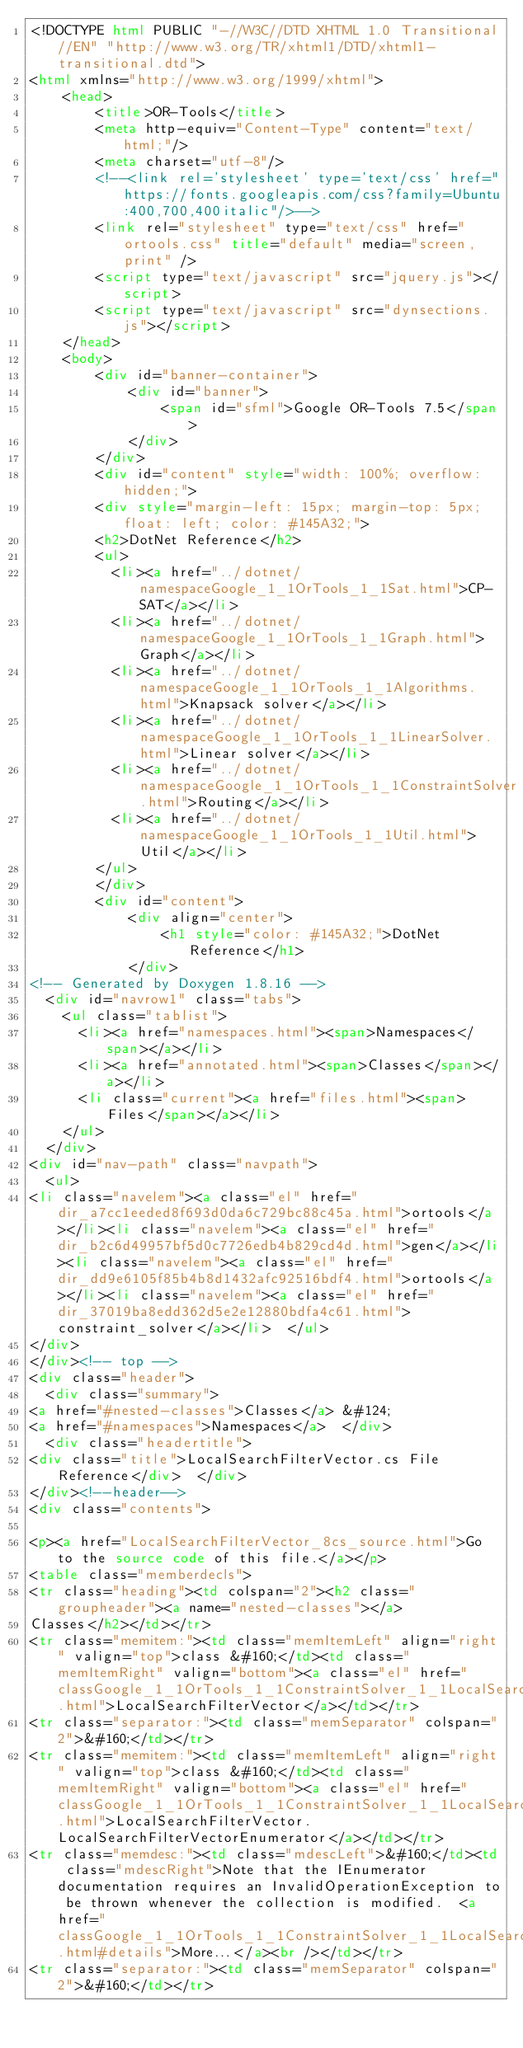Convert code to text. <code><loc_0><loc_0><loc_500><loc_500><_HTML_><!DOCTYPE html PUBLIC "-//W3C//DTD XHTML 1.0 Transitional//EN" "http://www.w3.org/TR/xhtml1/DTD/xhtml1-transitional.dtd">
<html xmlns="http://www.w3.org/1999/xhtml">
    <head>
        <title>OR-Tools</title>
        <meta http-equiv="Content-Type" content="text/html;"/>
        <meta charset="utf-8"/>
        <!--<link rel='stylesheet' type='text/css' href="https://fonts.googleapis.com/css?family=Ubuntu:400,700,400italic"/>-->
        <link rel="stylesheet" type="text/css" href="ortools.css" title="default" media="screen,print" />
        <script type="text/javascript" src="jquery.js"></script>
        <script type="text/javascript" src="dynsections.js"></script>
    </head>
    <body>
        <div id="banner-container">
            <div id="banner">
                <span id="sfml">Google OR-Tools 7.5</span>
            </div>
        </div>
        <div id="content" style="width: 100%; overflow: hidden;">
        <div style="margin-left: 15px; margin-top: 5px; float: left; color: #145A32;">
        <h2>DotNet Reference</h2>
        <ul>
          <li><a href="../dotnet/namespaceGoogle_1_1OrTools_1_1Sat.html">CP-SAT</a></li>
          <li><a href="../dotnet/namespaceGoogle_1_1OrTools_1_1Graph.html">Graph</a></li>
          <li><a href="../dotnet/namespaceGoogle_1_1OrTools_1_1Algorithms.html">Knapsack solver</a></li>
          <li><a href="../dotnet/namespaceGoogle_1_1OrTools_1_1LinearSolver.html">Linear solver</a></li>
          <li><a href="../dotnet/namespaceGoogle_1_1OrTools_1_1ConstraintSolver.html">Routing</a></li>
          <li><a href="../dotnet/namespaceGoogle_1_1OrTools_1_1Util.html">Util</a></li>
        </ul>
        </div>
        <div id="content">
            <div align="center">
                <h1 style="color: #145A32;">DotNet Reference</h1>
            </div>
<!-- Generated by Doxygen 1.8.16 -->
  <div id="navrow1" class="tabs">
    <ul class="tablist">
      <li><a href="namespaces.html"><span>Namespaces</span></a></li>
      <li><a href="annotated.html"><span>Classes</span></a></li>
      <li class="current"><a href="files.html"><span>Files</span></a></li>
    </ul>
  </div>
<div id="nav-path" class="navpath">
  <ul>
<li class="navelem"><a class="el" href="dir_a7cc1eeded8f693d0da6c729bc88c45a.html">ortools</a></li><li class="navelem"><a class="el" href="dir_b2c6d49957bf5d0c7726edb4b829cd4d.html">gen</a></li><li class="navelem"><a class="el" href="dir_dd9e6105f85b4b8d1432afc92516bdf4.html">ortools</a></li><li class="navelem"><a class="el" href="dir_37019ba8edd362d5e2e12880bdfa4c61.html">constraint_solver</a></li>  </ul>
</div>
</div><!-- top -->
<div class="header">
  <div class="summary">
<a href="#nested-classes">Classes</a> &#124;
<a href="#namespaces">Namespaces</a>  </div>
  <div class="headertitle">
<div class="title">LocalSearchFilterVector.cs File Reference</div>  </div>
</div><!--header-->
<div class="contents">

<p><a href="LocalSearchFilterVector_8cs_source.html">Go to the source code of this file.</a></p>
<table class="memberdecls">
<tr class="heading"><td colspan="2"><h2 class="groupheader"><a name="nested-classes"></a>
Classes</h2></td></tr>
<tr class="memitem:"><td class="memItemLeft" align="right" valign="top">class &#160;</td><td class="memItemRight" valign="bottom"><a class="el" href="classGoogle_1_1OrTools_1_1ConstraintSolver_1_1LocalSearchFilterVector.html">LocalSearchFilterVector</a></td></tr>
<tr class="separator:"><td class="memSeparator" colspan="2">&#160;</td></tr>
<tr class="memitem:"><td class="memItemLeft" align="right" valign="top">class &#160;</td><td class="memItemRight" valign="bottom"><a class="el" href="classGoogle_1_1OrTools_1_1ConstraintSolver_1_1LocalSearchFilterVector_1_1LocalSearchFilterVectorEnumerator.html">LocalSearchFilterVector.LocalSearchFilterVectorEnumerator</a></td></tr>
<tr class="memdesc:"><td class="mdescLeft">&#160;</td><td class="mdescRight">Note that the IEnumerator documentation requires an InvalidOperationException to be thrown whenever the collection is modified.  <a href="classGoogle_1_1OrTools_1_1ConstraintSolver_1_1LocalSearchFilterVector_1_1LocalSearchFilterVectorEnumerator.html#details">More...</a><br /></td></tr>
<tr class="separator:"><td class="memSeparator" colspan="2">&#160;</td></tr></code> 